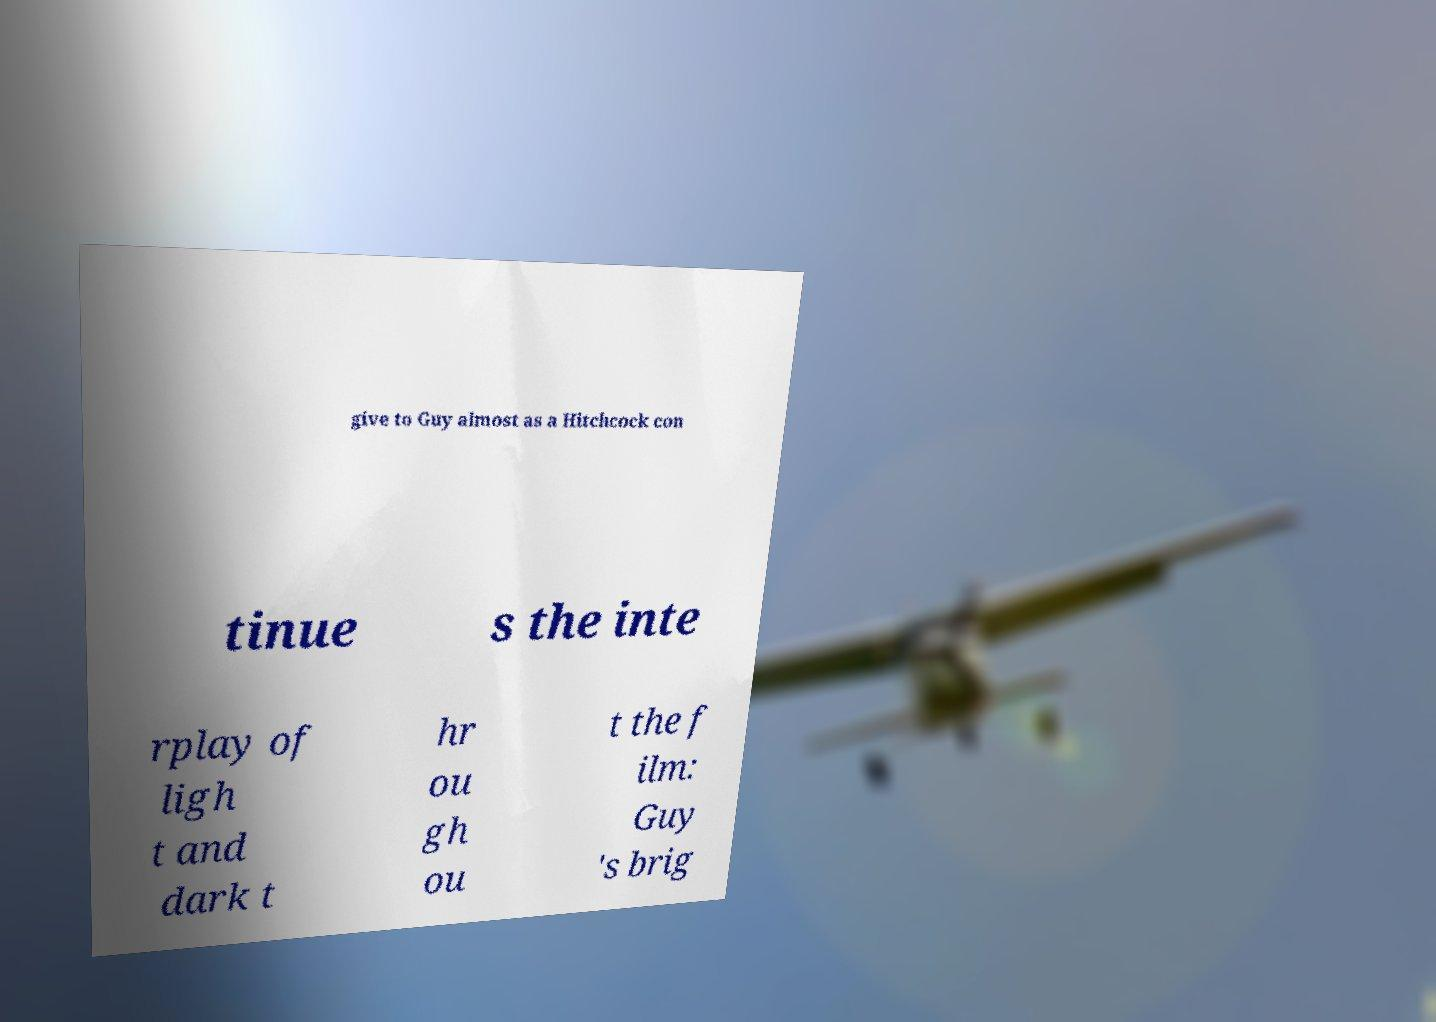What messages or text are displayed in this image? I need them in a readable, typed format. give to Guy almost as a Hitchcock con tinue s the inte rplay of ligh t and dark t hr ou gh ou t the f ilm: Guy 's brig 